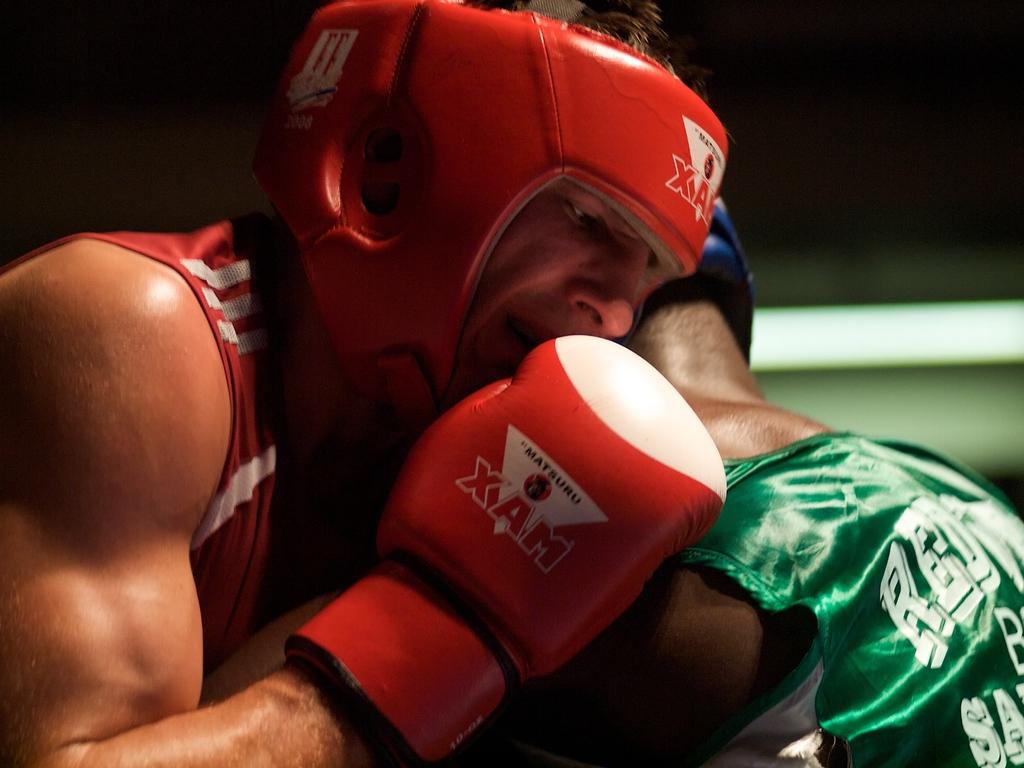What brand are those boxing glovs?
Provide a short and direct response. Xam. What are the first three letters of the green t-shirt player?
Provide a short and direct response. Red. 